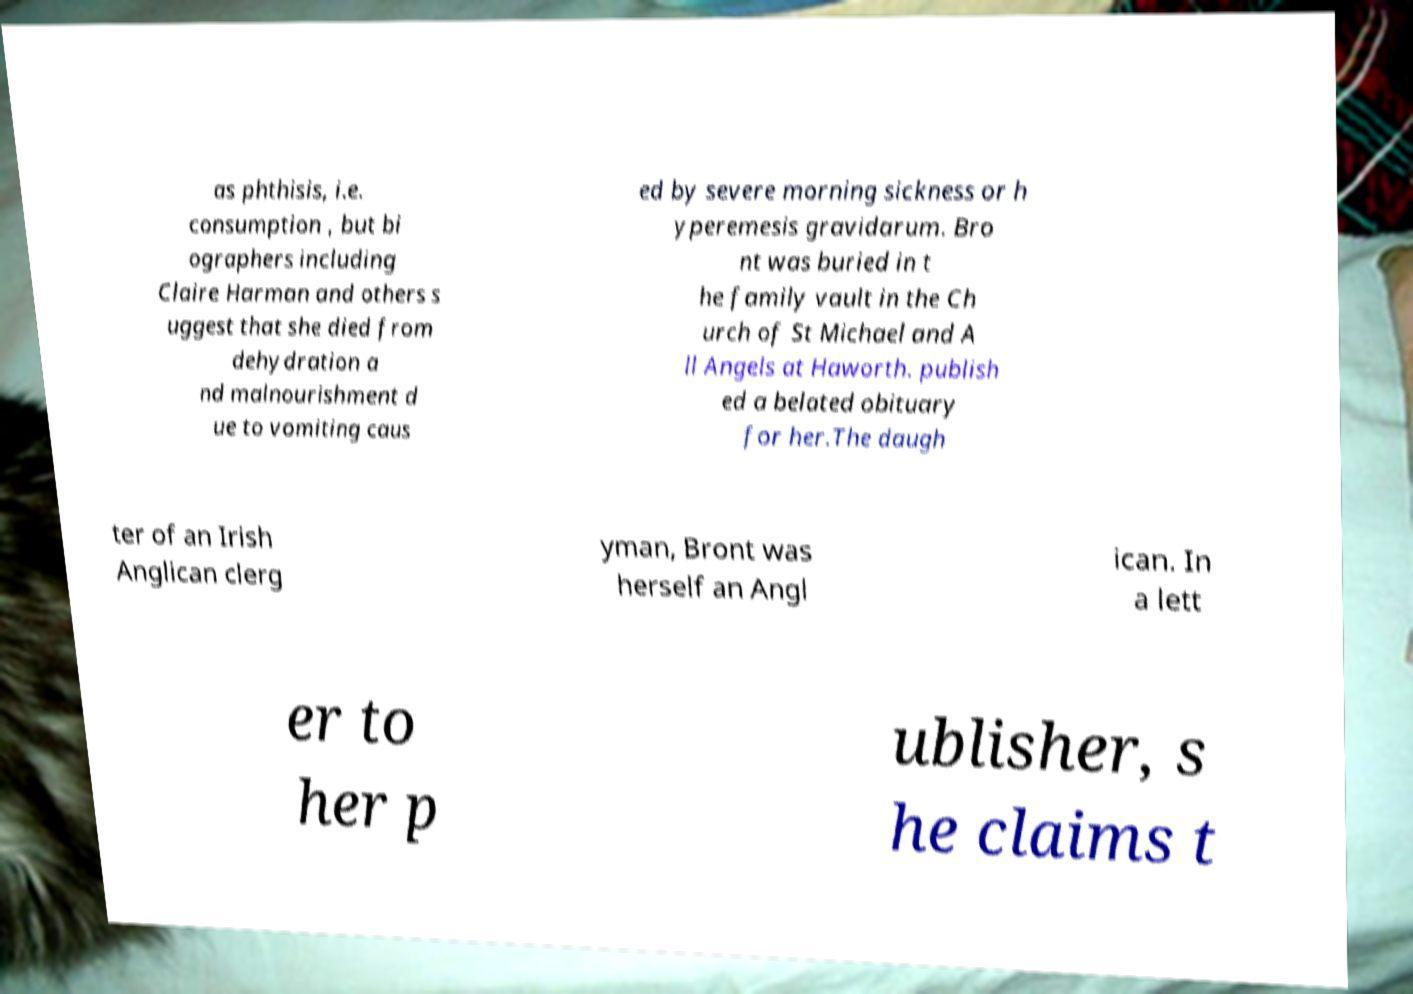Can you read and provide the text displayed in the image?This photo seems to have some interesting text. Can you extract and type it out for me? as phthisis, i.e. consumption , but bi ographers including Claire Harman and others s uggest that she died from dehydration a nd malnourishment d ue to vomiting caus ed by severe morning sickness or h yperemesis gravidarum. Bro nt was buried in t he family vault in the Ch urch of St Michael and A ll Angels at Haworth. publish ed a belated obituary for her.The daugh ter of an Irish Anglican clerg yman, Bront was herself an Angl ican. In a lett er to her p ublisher, s he claims t 